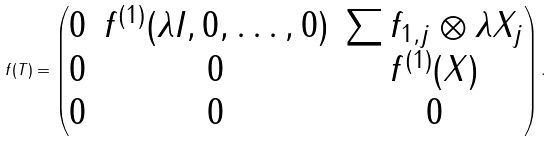Convert formula to latex. <formula><loc_0><loc_0><loc_500><loc_500>f ( T ) = \begin{pmatrix} 0 & f ^ { ( 1 ) } ( \lambda I , 0 , \dots , 0 ) & \sum f _ { 1 , j } \otimes \lambda X _ { j } \\ 0 & 0 & f ^ { ( 1 ) } ( X ) \\ 0 & 0 & 0 \end{pmatrix} .</formula> 